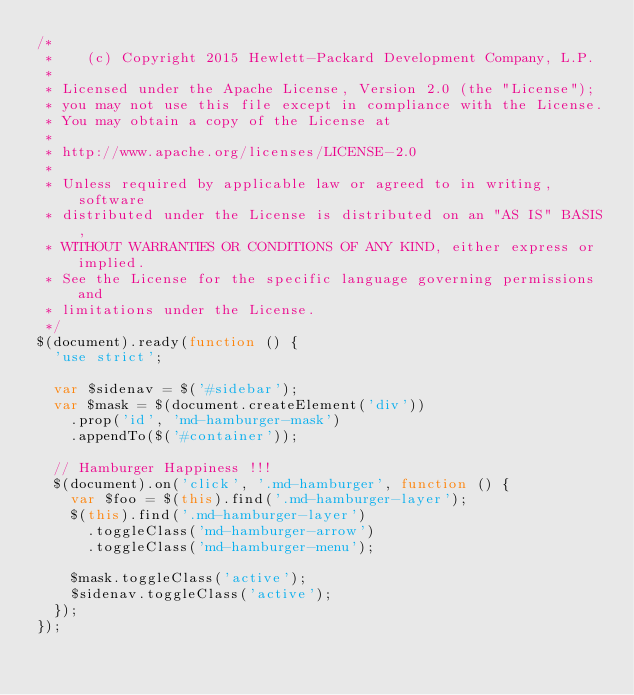Convert code to text. <code><loc_0><loc_0><loc_500><loc_500><_JavaScript_>/*
 *    (c) Copyright 2015 Hewlett-Packard Development Company, L.P.
 *
 * Licensed under the Apache License, Version 2.0 (the "License");
 * you may not use this file except in compliance with the License.
 * You may obtain a copy of the License at
 *
 * http://www.apache.org/licenses/LICENSE-2.0
 *
 * Unless required by applicable law or agreed to in writing, software
 * distributed under the License is distributed on an "AS IS" BASIS,
 * WITHOUT WARRANTIES OR CONDITIONS OF ANY KIND, either express or implied.
 * See the License for the specific language governing permissions and
 * limitations under the License.
 */
$(document).ready(function () {
  'use strict';

  var $sidenav = $('#sidebar');
  var $mask = $(document.createElement('div'))
    .prop('id', 'md-hamburger-mask')
    .appendTo($('#container'));

  // Hamburger Happiness !!!
  $(document).on('click', '.md-hamburger', function () {
    var $foo = $(this).find('.md-hamburger-layer');
    $(this).find('.md-hamburger-layer')
      .toggleClass('md-hamburger-arrow')
      .toggleClass('md-hamburger-menu');

    $mask.toggleClass('active');
    $sidenav.toggleClass('active');
  });
});
</code> 